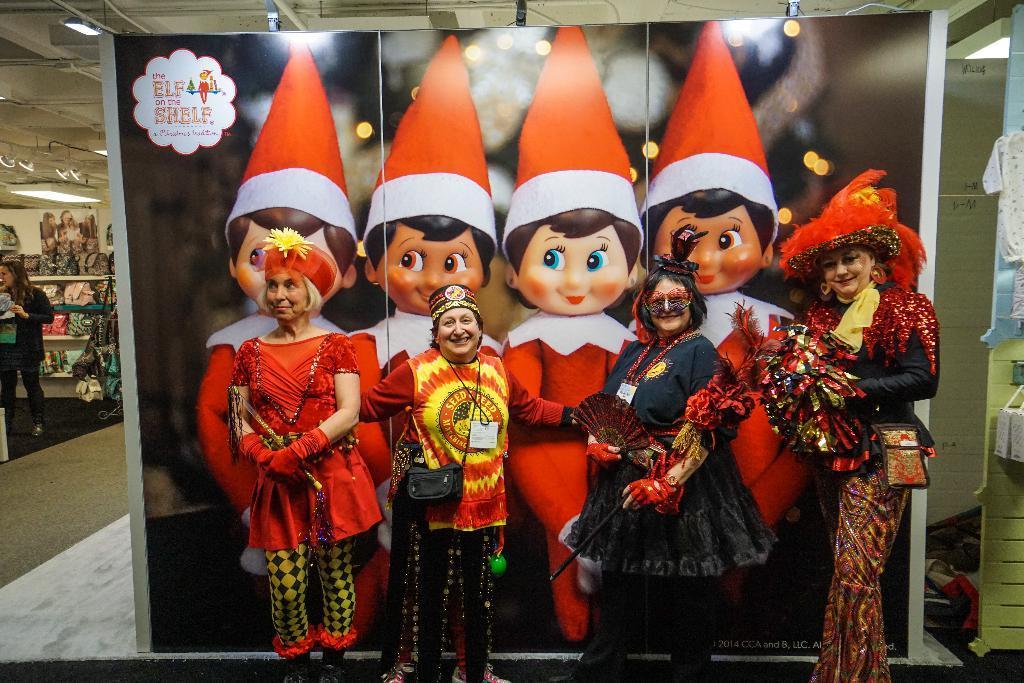Can you describe this image briefly? In this image we can see four women wearing costume are standing on the floor. One woman is wearing a bag and cap. In the background, we can see a woman in black dress standing, a banner ,group of bags placed in a rack, a group of lights and clothes. 